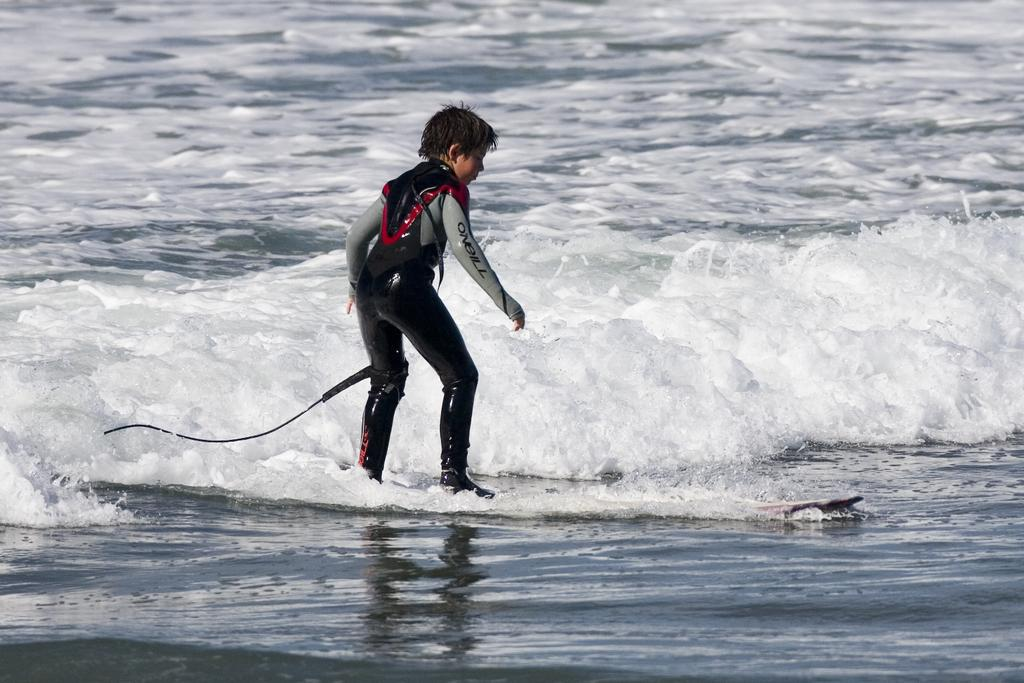<image>
Share a concise interpretation of the image provided. A boy wearing an Oneill swimsuit near a wave on a board. 